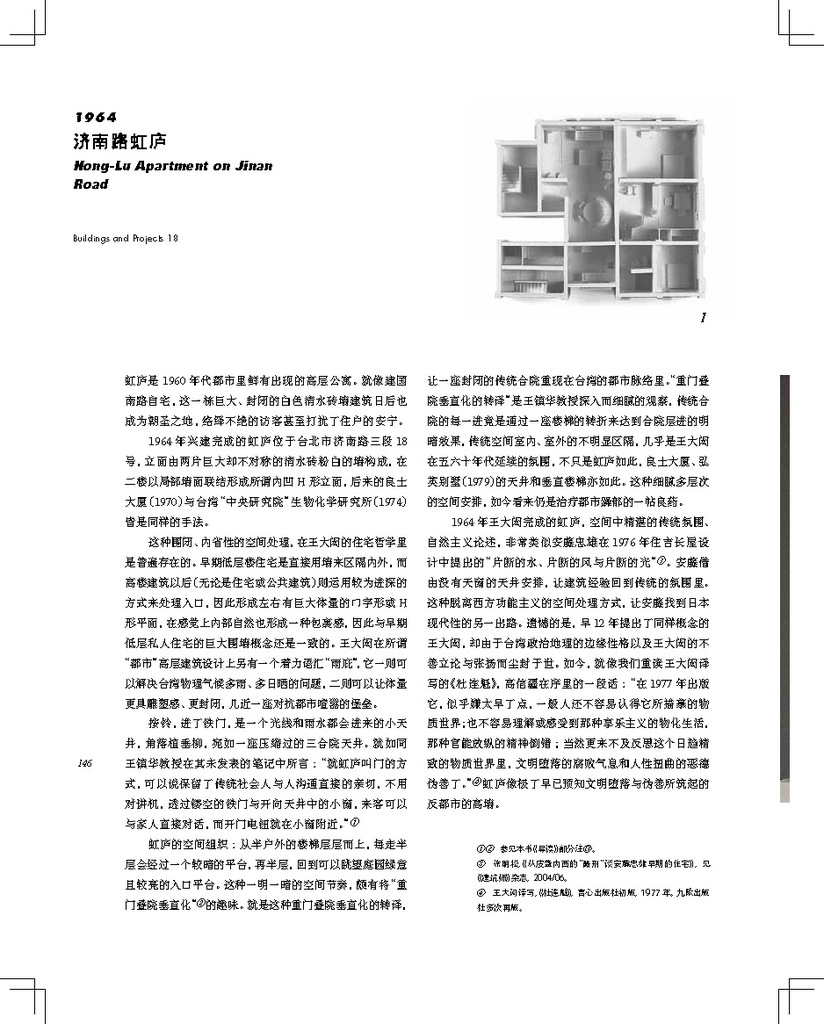What does the text surrounding the image likely discuss? The text likely provides context about the Hong Lu apartment, such as its architectural significance, construction history, and the design philosophy behind its creation. 